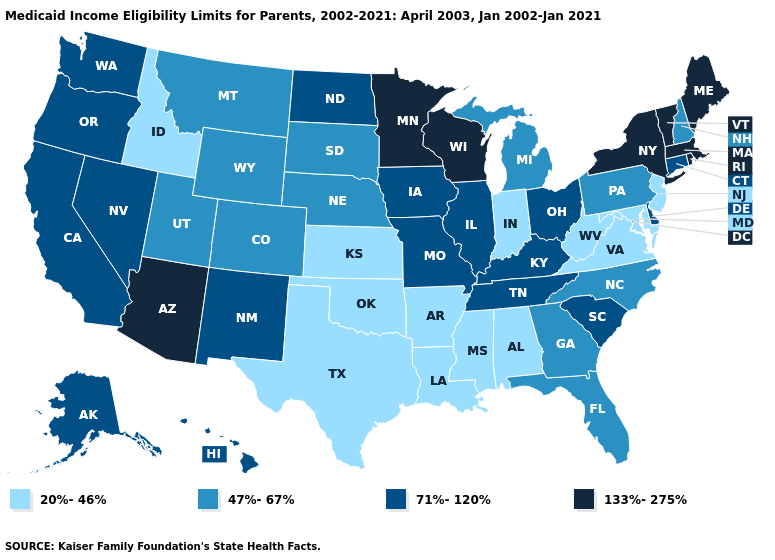Does Virginia have the highest value in the USA?
Answer briefly. No. Which states have the highest value in the USA?
Write a very short answer. Arizona, Maine, Massachusetts, Minnesota, New York, Rhode Island, Vermont, Wisconsin. Name the states that have a value in the range 71%-120%?
Be succinct. Alaska, California, Connecticut, Delaware, Hawaii, Illinois, Iowa, Kentucky, Missouri, Nevada, New Mexico, North Dakota, Ohio, Oregon, South Carolina, Tennessee, Washington. What is the value of Missouri?
Be succinct. 71%-120%. Among the states that border Missouri , which have the highest value?
Be succinct. Illinois, Iowa, Kentucky, Tennessee. Does Wisconsin have the highest value in the USA?
Be succinct. Yes. What is the lowest value in the USA?
Short answer required. 20%-46%. What is the lowest value in the USA?
Concise answer only. 20%-46%. What is the highest value in the MidWest ?
Concise answer only. 133%-275%. What is the value of Maine?
Give a very brief answer. 133%-275%. Does Indiana have the lowest value in the USA?
Keep it brief. Yes. What is the lowest value in the Northeast?
Answer briefly. 20%-46%. Does the map have missing data?
Quick response, please. No. What is the value of Utah?
Short answer required. 47%-67%. Does Massachusetts have a higher value than New Hampshire?
Be succinct. Yes. 